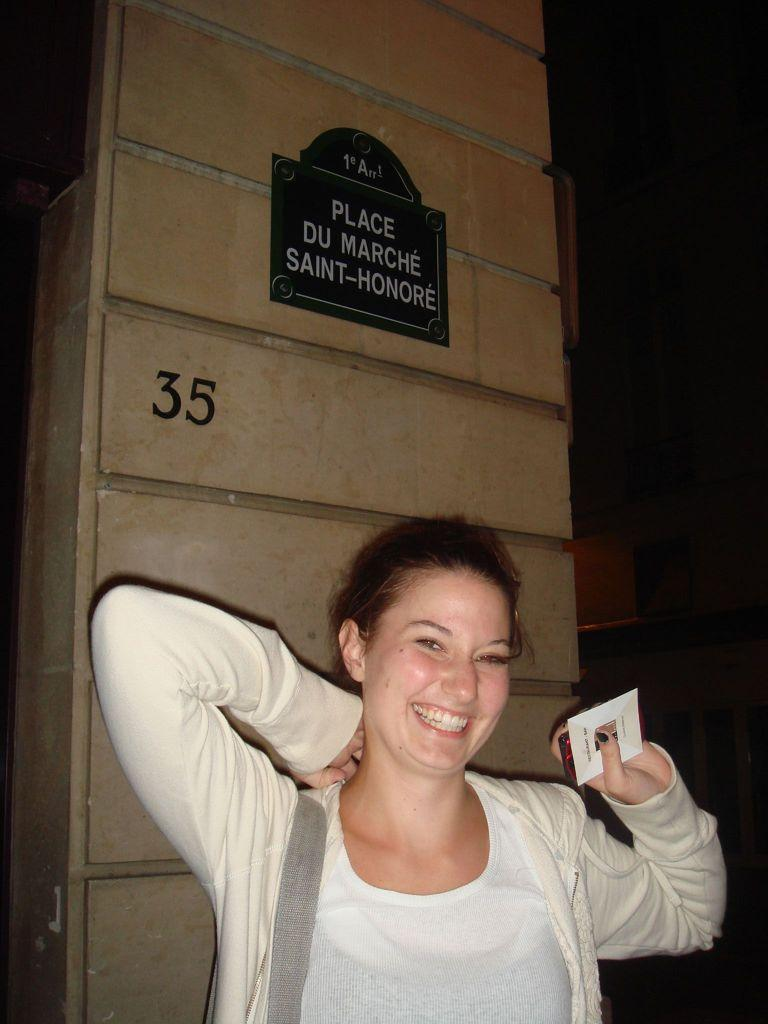Who is present in the image? There is a woman in the image. What is the woman holding in the image? The woman is holding a card. What is the woman's facial expression in the image? The woman is smiling. What can be seen in the background of the image? There is a board in the background of the image, and there are numbers on a pillar. Can you tell me how many loaves of bread are on the horse in the image? There is no horse or loaves of bread present in the image. What act is the woman performing with the card in the image? The image does not depict the woman performing any specific act with the card; she is simply holding it. 